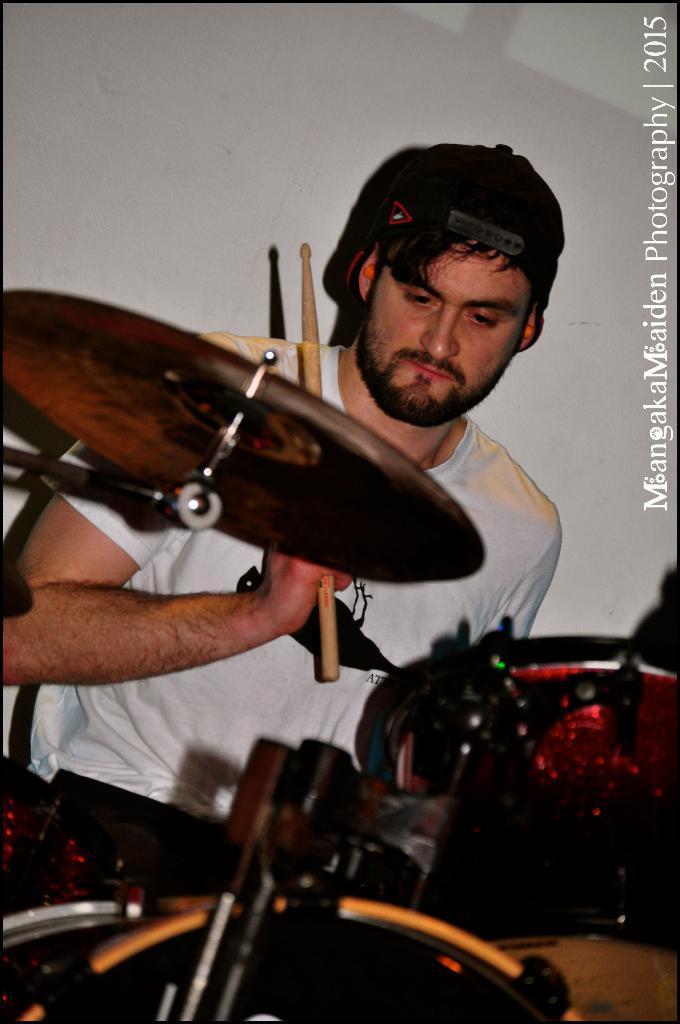Please provide a concise description of this image. In this image I see a man who is holding the sticks and there is an musical instrument in front of him. 